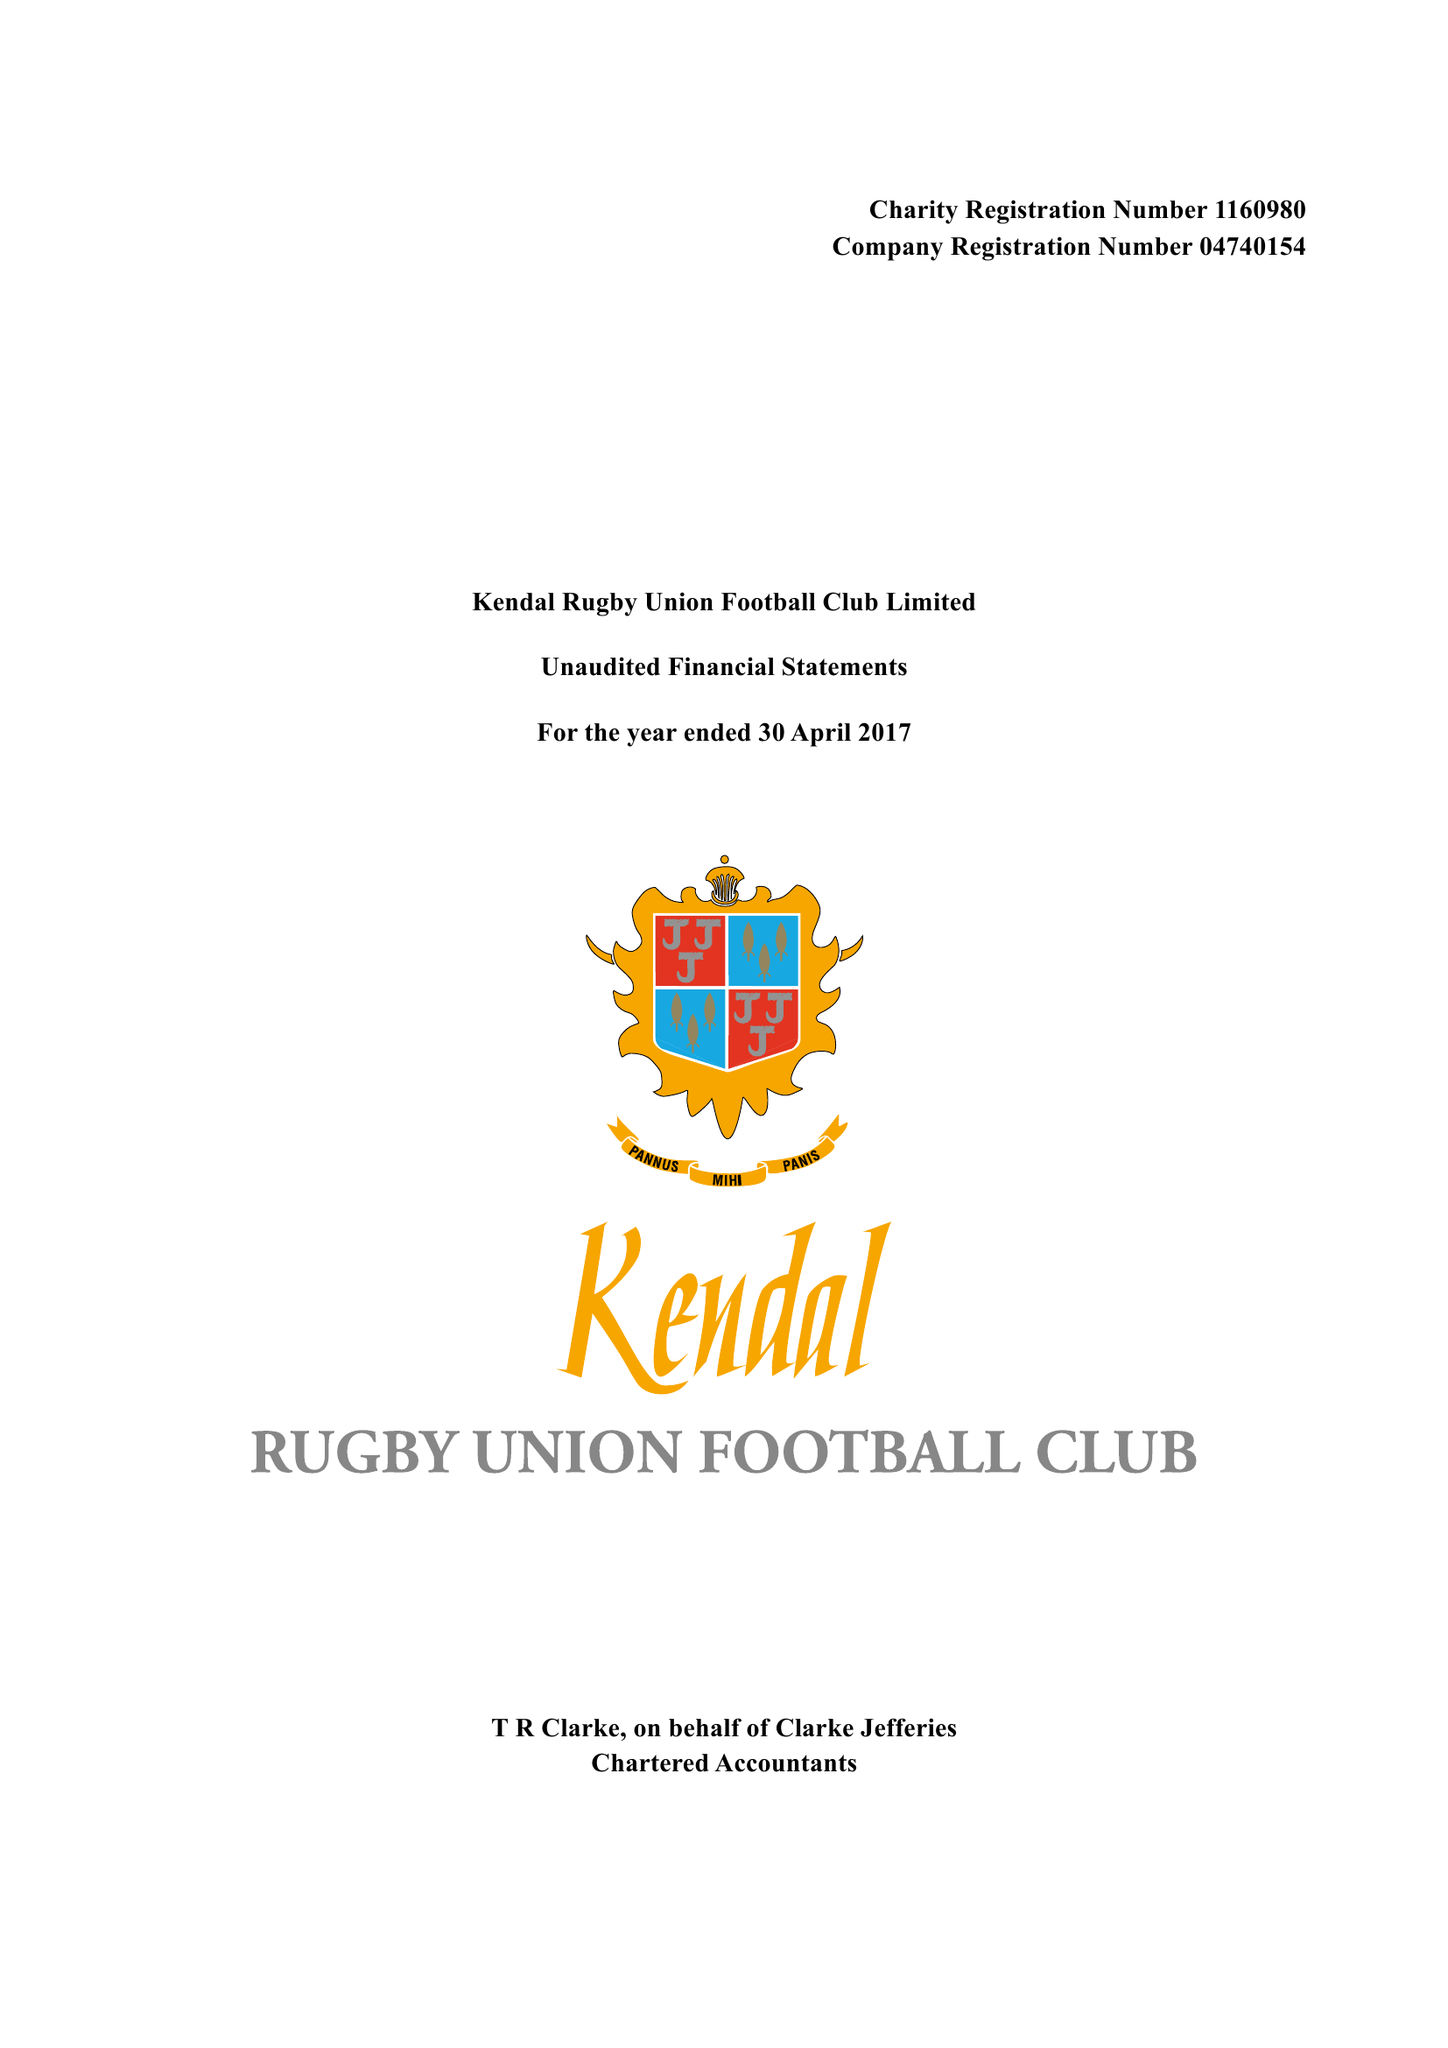What is the value for the address__street_line?
Answer the question using a single word or phrase. SHAP ROAD 